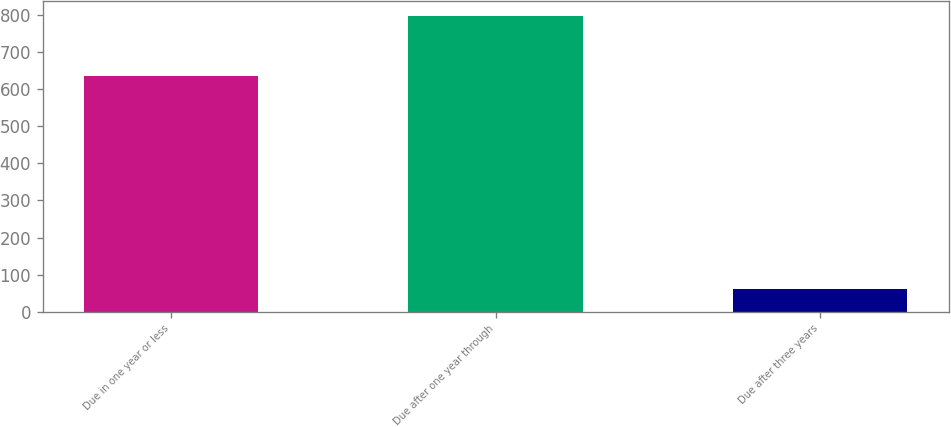Convert chart to OTSL. <chart><loc_0><loc_0><loc_500><loc_500><bar_chart><fcel>Due in one year or less<fcel>Due after one year through<fcel>Due after three years<nl><fcel>635.3<fcel>797<fcel>62.2<nl></chart> 